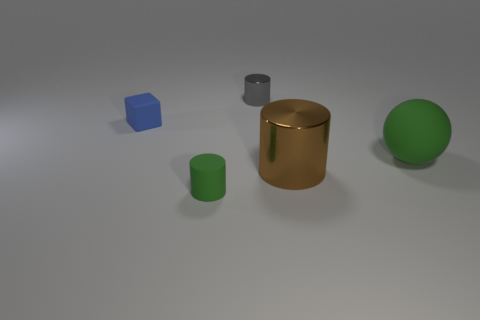What time of day does the lighting in this scene suggest? The lighting in the scene doesn't strongly suggest a particular time of day as it appears to be a controlled indoor environment with soft, diffuse lighting coming from an overhead source, likely artificial. 